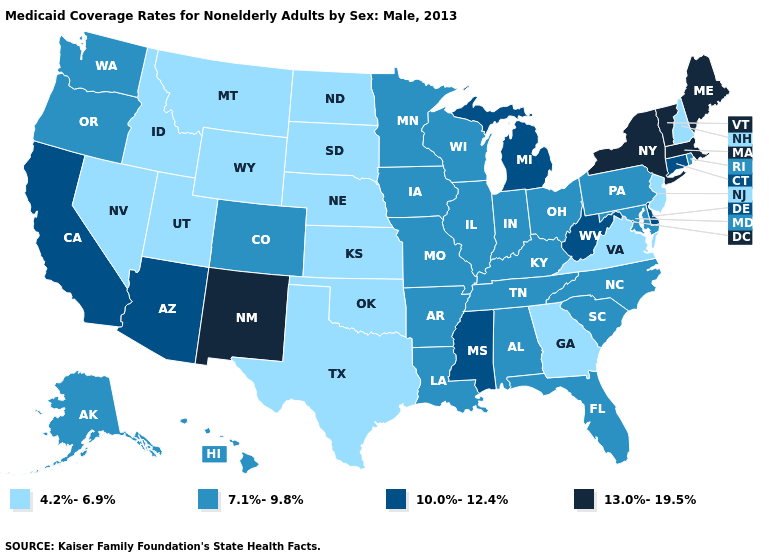Name the states that have a value in the range 4.2%-6.9%?
Concise answer only. Georgia, Idaho, Kansas, Montana, Nebraska, Nevada, New Hampshire, New Jersey, North Dakota, Oklahoma, South Dakota, Texas, Utah, Virginia, Wyoming. Does North Dakota have the highest value in the MidWest?
Quick response, please. No. Does the map have missing data?
Concise answer only. No. Name the states that have a value in the range 10.0%-12.4%?
Short answer required. Arizona, California, Connecticut, Delaware, Michigan, Mississippi, West Virginia. What is the value of New Mexico?
Give a very brief answer. 13.0%-19.5%. Name the states that have a value in the range 4.2%-6.9%?
Keep it brief. Georgia, Idaho, Kansas, Montana, Nebraska, Nevada, New Hampshire, New Jersey, North Dakota, Oklahoma, South Dakota, Texas, Utah, Virginia, Wyoming. What is the highest value in the USA?
Give a very brief answer. 13.0%-19.5%. What is the lowest value in the South?
Short answer required. 4.2%-6.9%. Name the states that have a value in the range 13.0%-19.5%?
Concise answer only. Maine, Massachusetts, New Mexico, New York, Vermont. Does the first symbol in the legend represent the smallest category?
Short answer required. Yes. What is the value of Texas?
Give a very brief answer. 4.2%-6.9%. Does Minnesota have a higher value than Montana?
Answer briefly. Yes. What is the value of California?
Keep it brief. 10.0%-12.4%. What is the highest value in the West ?
Quick response, please. 13.0%-19.5%. What is the value of New Hampshire?
Quick response, please. 4.2%-6.9%. 